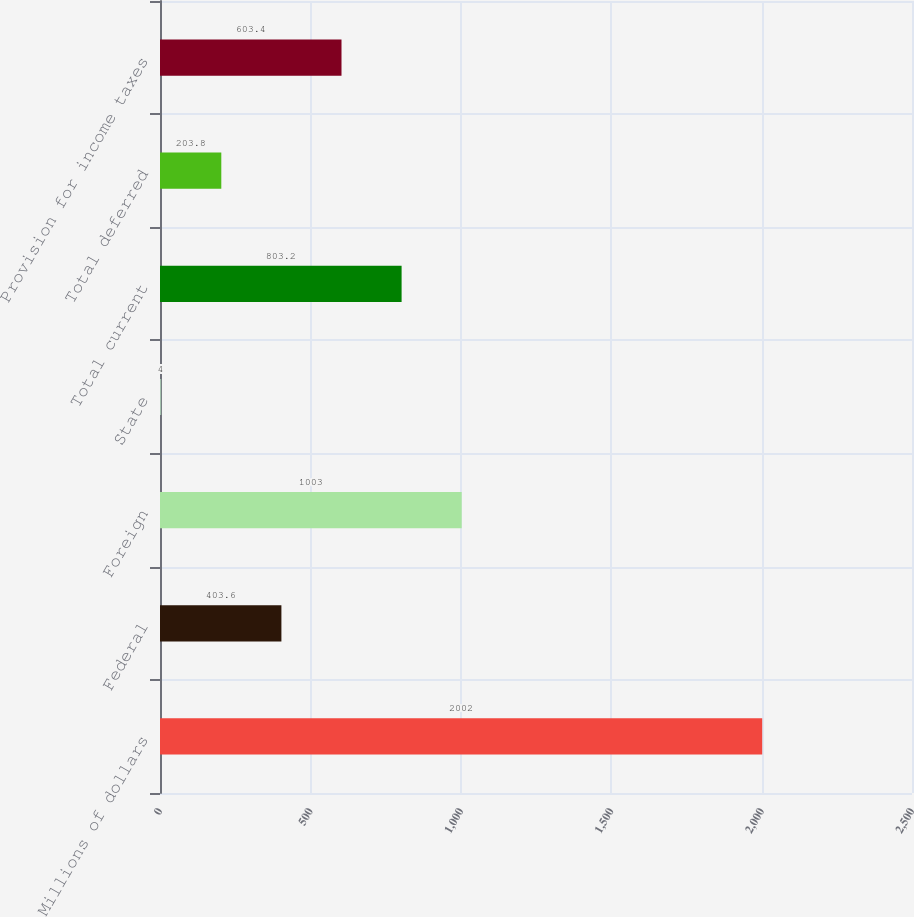<chart> <loc_0><loc_0><loc_500><loc_500><bar_chart><fcel>Millions of dollars<fcel>Federal<fcel>Foreign<fcel>State<fcel>Total current<fcel>Total deferred<fcel>Provision for income taxes<nl><fcel>2002<fcel>403.6<fcel>1003<fcel>4<fcel>803.2<fcel>203.8<fcel>603.4<nl></chart> 